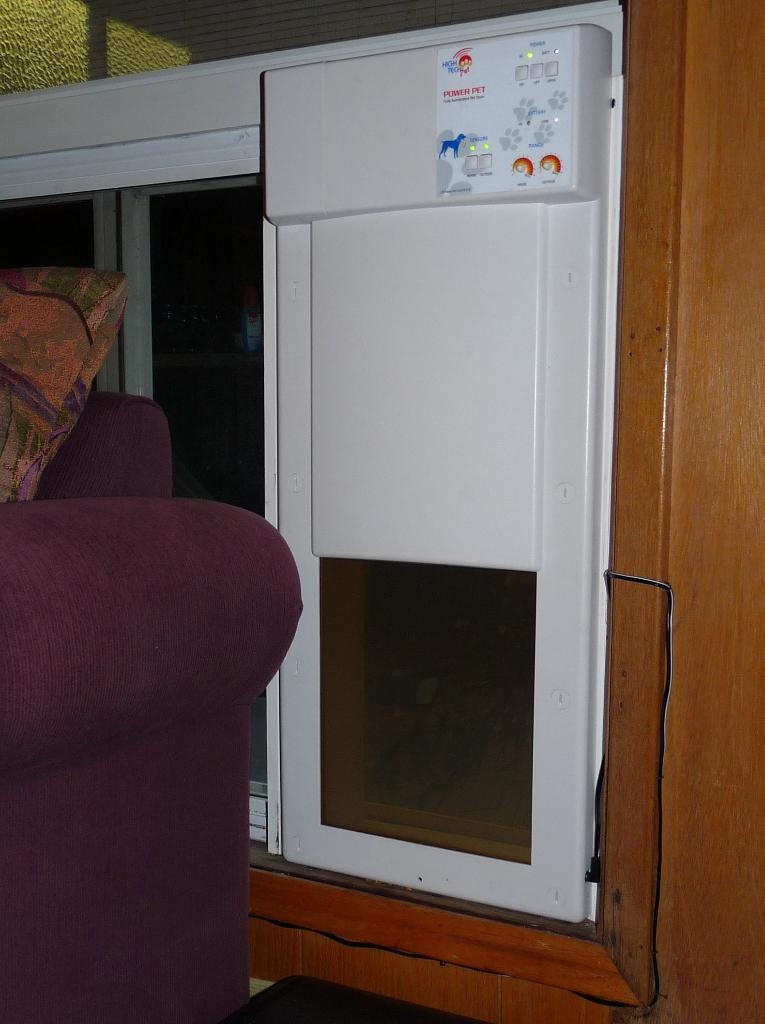<image>
Describe the image concisely. The exterior view of a Power Pet dog drier. 